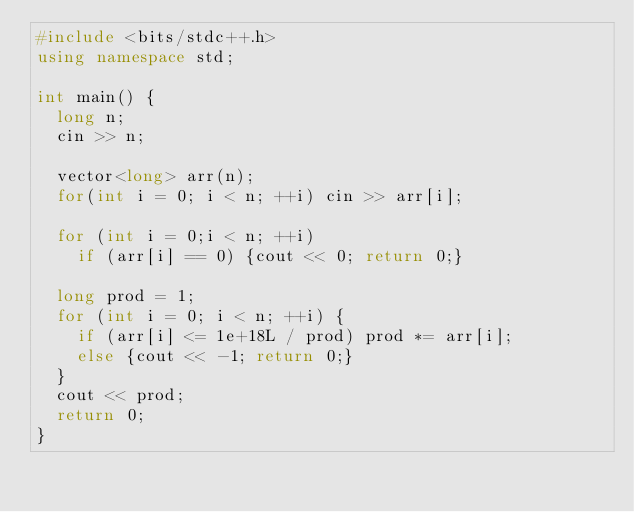<code> <loc_0><loc_0><loc_500><loc_500><_C++_>#include <bits/stdc++.h>
using namespace std;

int main() {
  long n;
  cin >> n;
  
  vector<long> arr(n);
  for(int i = 0; i < n; ++i) cin >> arr[i];
  
  for (int i = 0;i < n; ++i) 
    if (arr[i] == 0) {cout << 0; return 0;}
  
  long prod = 1;
  for (int i = 0; i < n; ++i) {
    if (arr[i] <= 1e+18L / prod) prod *= arr[i];
    else {cout << -1; return 0;}
  }
  cout << prod;
  return 0;
}
      </code> 